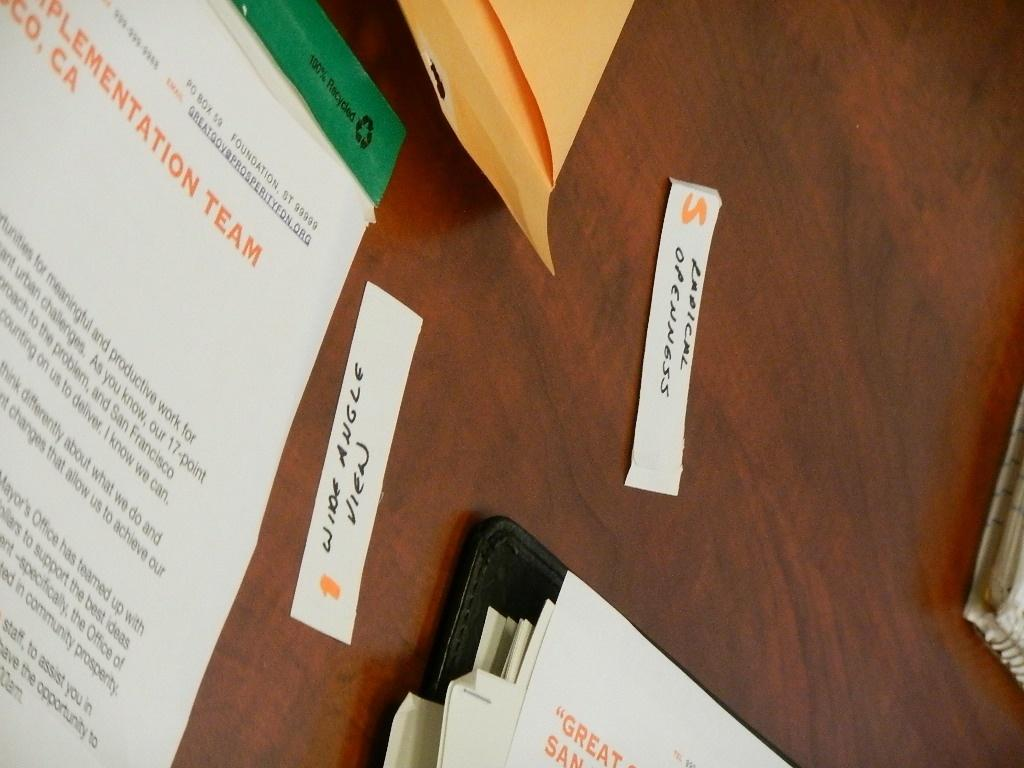<image>
Present a compact description of the photo's key features. A table showing a few documents for an implementation team 